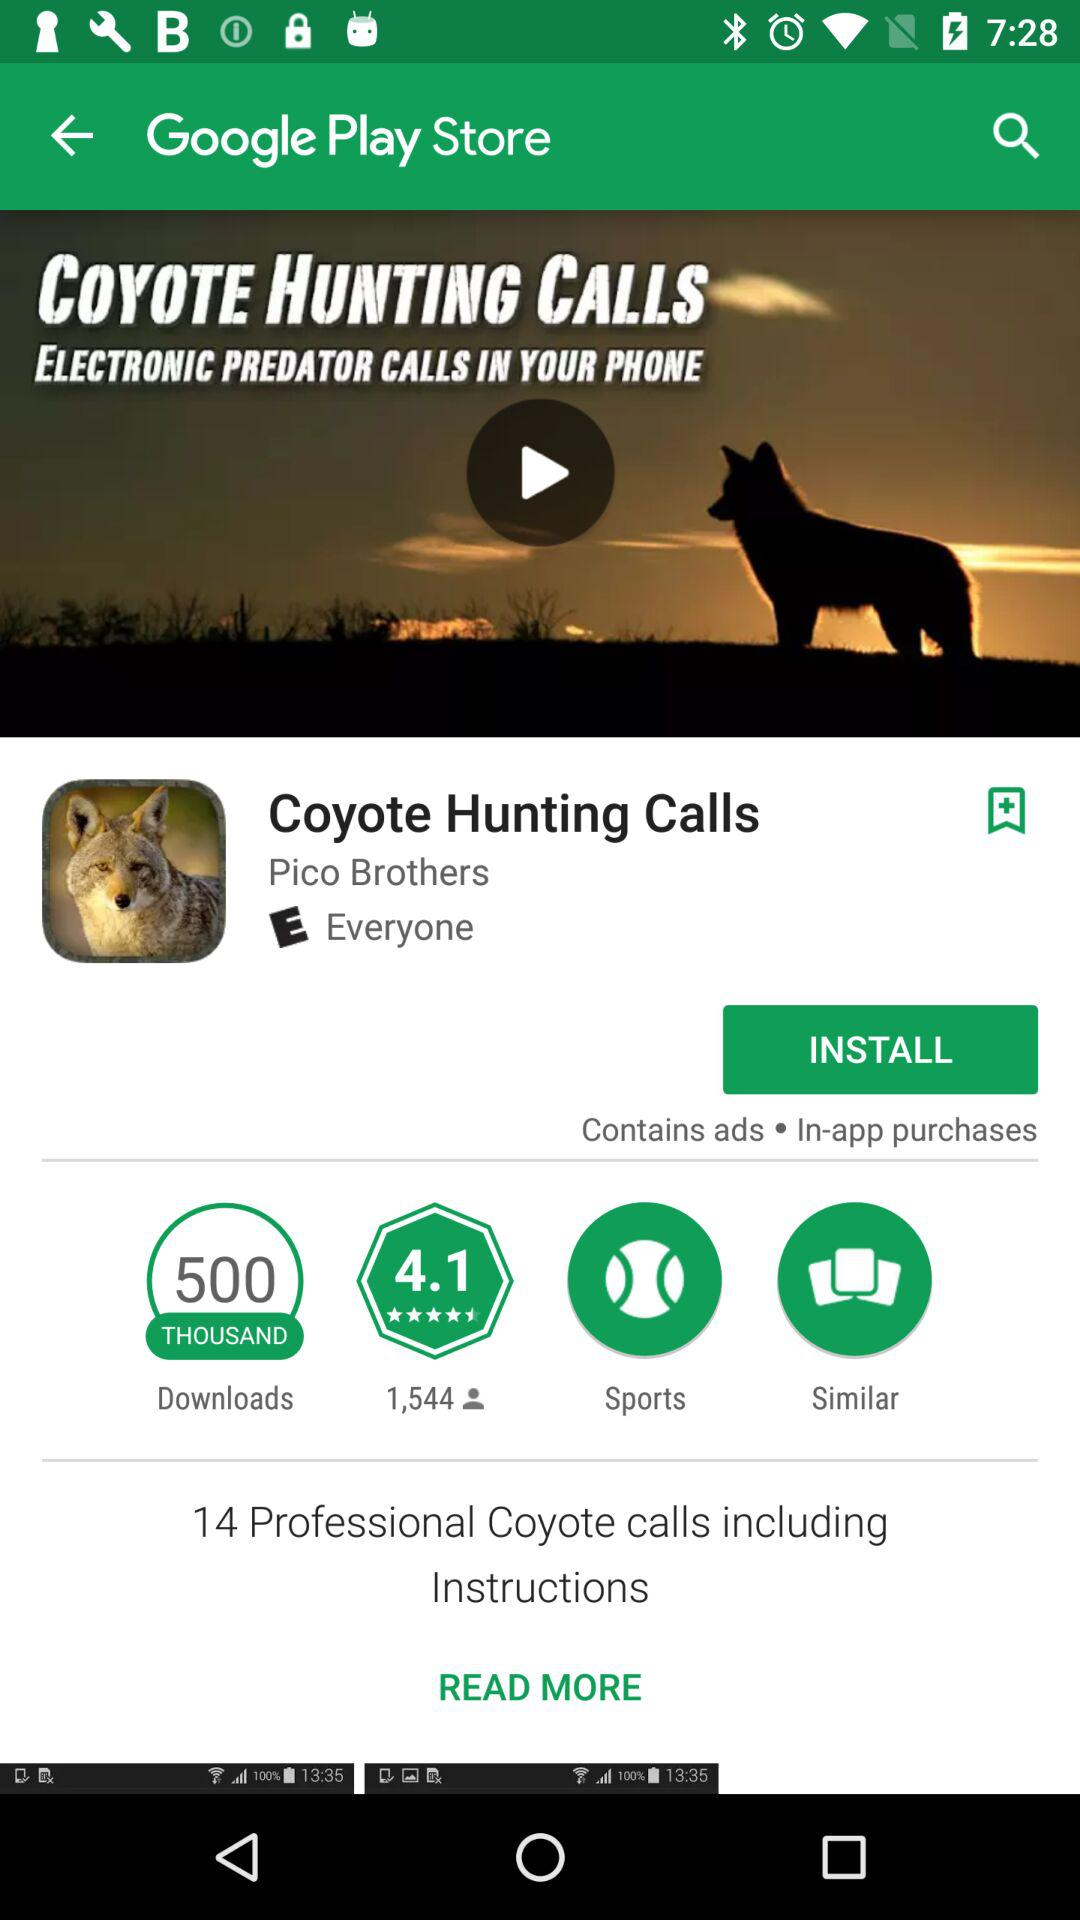How many "Professional Coyote calls including Instructions" are there? There are 14 "Professional Coyote calls including Instructions". 